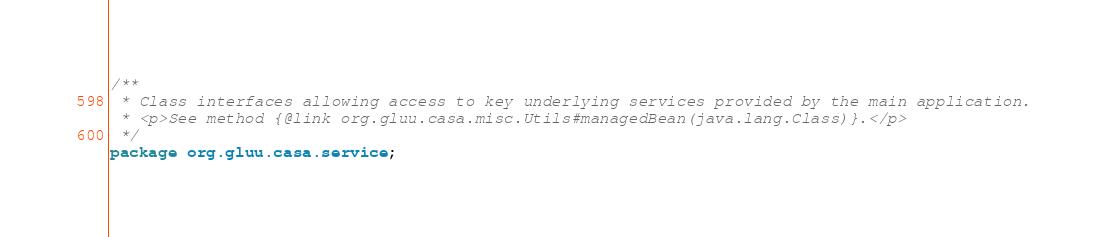<code> <loc_0><loc_0><loc_500><loc_500><_Java_>/**
 * Class interfaces allowing access to key underlying services provided by the main application.
 * <p>See method {@link org.gluu.casa.misc.Utils#managedBean(java.lang.Class)}.</p>
 */
package org.gluu.casa.service;
</code> 